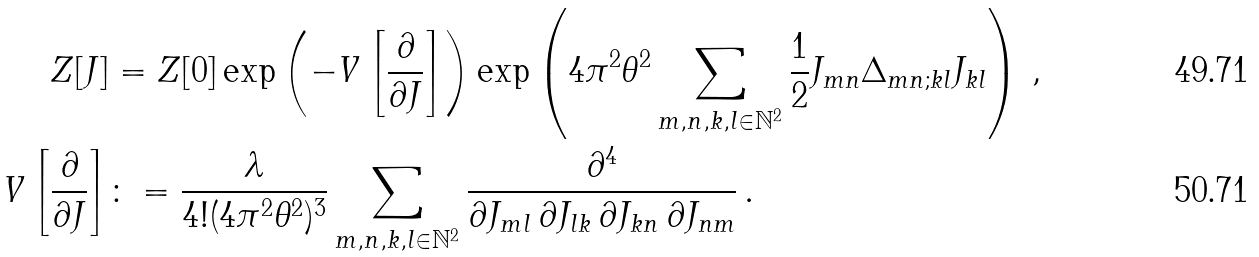Convert formula to latex. <formula><loc_0><loc_0><loc_500><loc_500>Z [ J ] & = Z [ 0 ] \exp \left ( - V \left [ \frac { \partial } { \partial J } \right ] \right ) \exp \left ( 4 \pi ^ { 2 } \theta ^ { 2 } \sum _ { m , n , k , l \in \mathbb { N } ^ { 2 } } \frac { 1 } { 2 } J _ { m n } \Delta _ { m n ; k l } J _ { k l } \right ) \, , \\ V \left [ \frac { \partial } { \partial J } \right ] & \colon = \frac { \lambda } { 4 ! ( 4 \pi ^ { 2 } \theta ^ { 2 } ) ^ { 3 } } \sum _ { m , n , k , l \in \mathbb { N } ^ { 2 } } \frac { \partial ^ { 4 } } { \partial J _ { m l } \, \partial J _ { l k } \, \partial J _ { k n } \, \partial J _ { n m } } \, .</formula> 